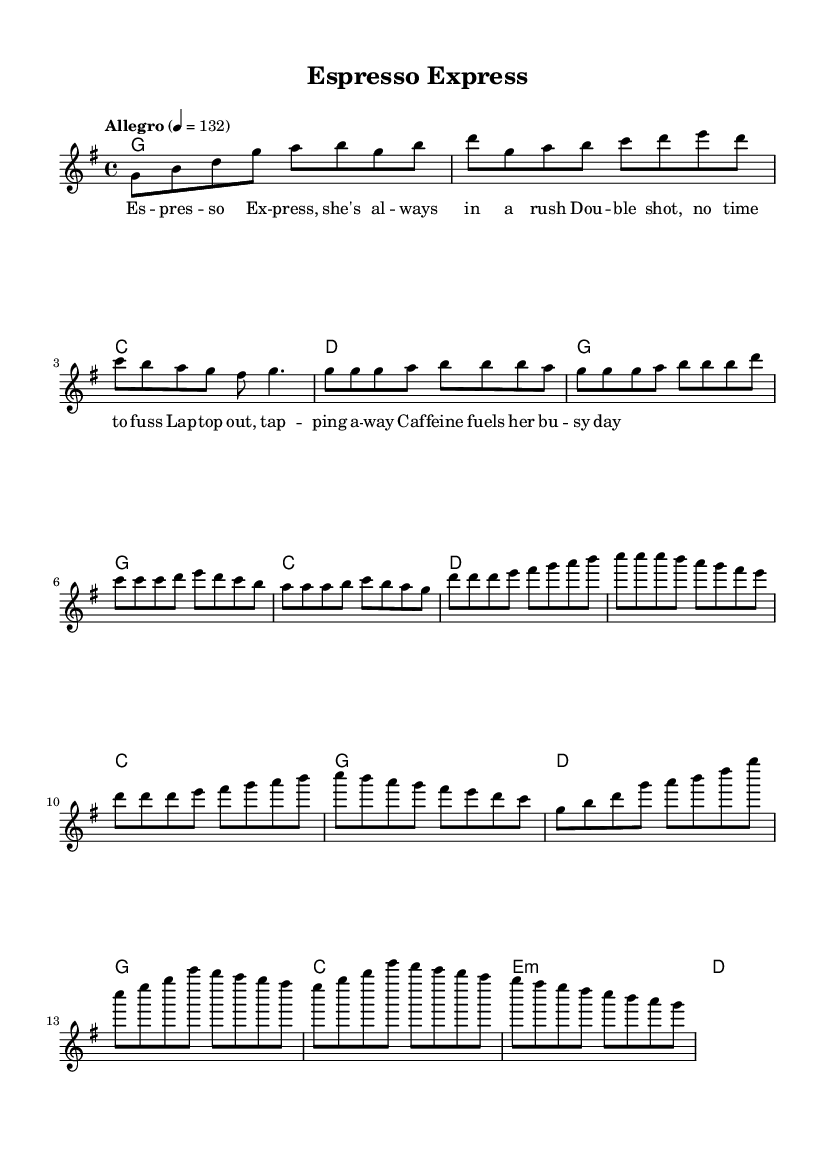What is the key signature of this music? The key signature is G major, which has one sharp (F#). This can be identified by looking at the key signature symbol at the beginning of the staff.
Answer: G major What is the time signature of this music? The time signature is 4/4, indicating that there are four beats in each measure and the quarter note receives one beat. This is seen at the beginning of the staff, where the time signature is displayed.
Answer: 4/4 What is the tempo marking of this music? The tempo marking is "Allegro," which indicates a fast and lively tempo, specifically at 132 beats per minute. The tempo is noted at the beginning in the tempo indication.
Answer: Allegro How many measures are there in the verse section? To find the number of measures in the verse section, we can count the distinct sections written in the music. The verse spans eight measures, as indicated by how it is structured across the staves.
Answer: Eight measures What type of chord is used in the chorus? The chorus section specifically uses a minor chord, indicated by the e:m notation which means E minor chord is played in that measure. This shows a distinct characteristic of K-Pop using varied harmonies to enhance the mood.
Answer: E minor Which musical technique is primarily utilized in the melody? The melody primarily utilizes syncopation, a rhythmic technique where the emphasis is placed on the off-beat notes, creating a unique rhythmic feel often found in K-Pop. This can be observed in the way the notes fall against the chords in various sections.
Answer: Syncopation 